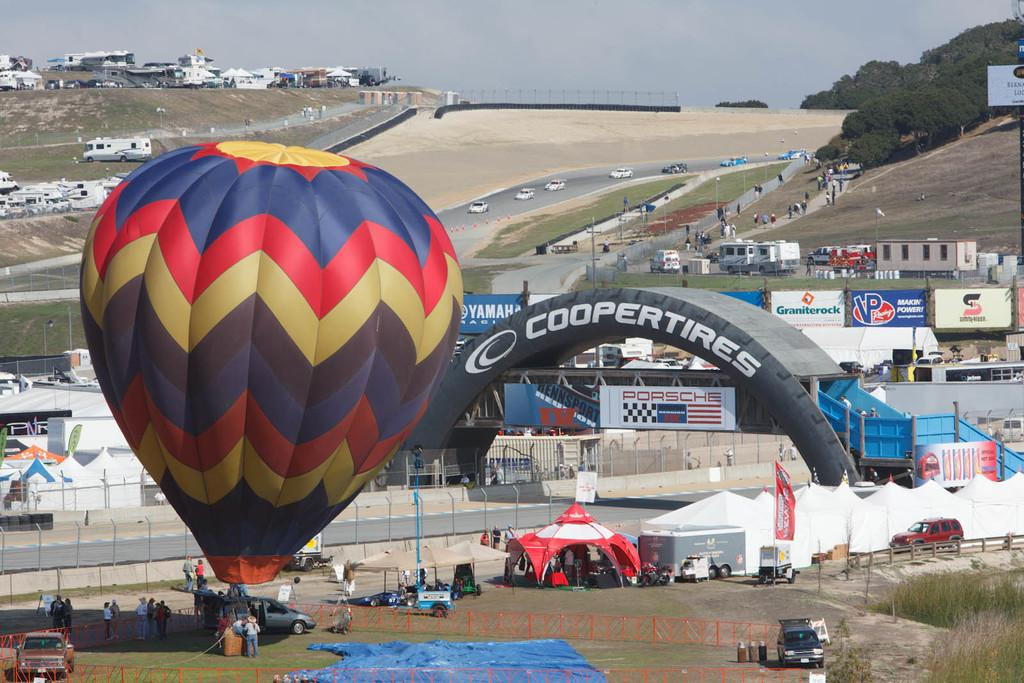<image>
Provide a brief description of the given image. A large and colorful hot air balloon at a Coopertires event. 